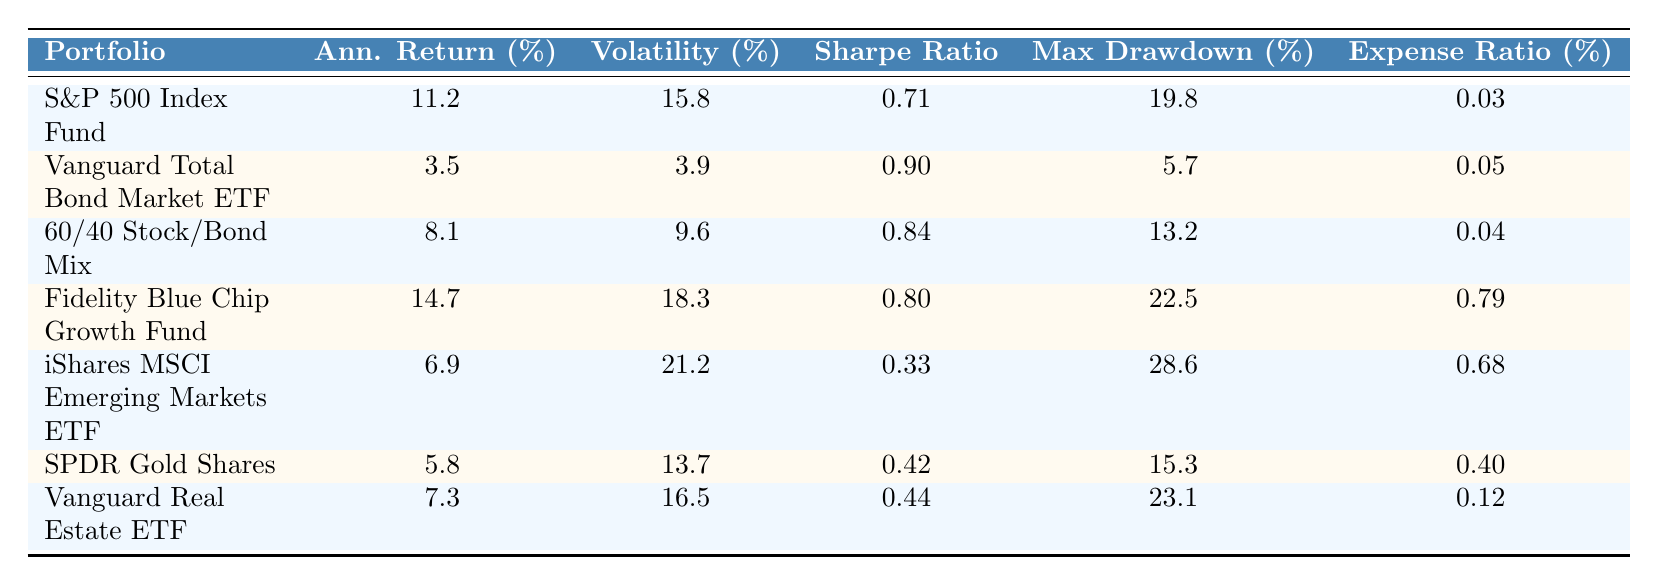What's the annualized return of the Fidelity Blue Chip Growth Fund? Referring to the table, the Fidelity Blue Chip Growth Fund's annualized return is explicitly listed as 14.7%.
Answer: 14.7% Which portfolio has the highest Sharpe Ratio? The Sharpe Ratio for each portfolio is compared. The Vanguard Total Bond Market ETF has a Sharpe Ratio of 0.90, which is the highest among all portfolios listed.
Answer: Vanguard Total Bond Market ETF What is the average maximum drawdown of all the portfolios? To find the average, sum the maximum drawdowns: 19.8 + 5.7 + 13.2 + 22.5 + 28.6 + 15.3 + 23.1 = 128.2. There are 7 portfolios, so the average is 128.2 / 7 ≈ 18.3%.
Answer: 18.3% Is the expense ratio of the iShares MSCI Emerging Markets ETF higher than that of the Vanguard Total Bond Market ETF? The expense ratio of the iShares MSCI Emerging Markets ETF is 0.68%, while the Vanguard Total Bond Market ETF's is 0.05%. Since 0.68% is greater than 0.05%, the statement is true.
Answer: Yes What is the difference in annualized return between the S&P 500 Index Fund and the 60/40 Stock/Bond Mix? The annualized return of the S&P 500 Index Fund is 11.2%, and for the 60/40 Stock/Bond Mix, it is 8.1%. The difference is 11.2 - 8.1 = 3.1%.
Answer: 3.1% Which portfolio has the lowest volatility, and what is that value? Upon examining the volatility values in the table, the Vanguard Total Bond Market ETF has the lowest volatility at 3.9%.
Answer: Vanguard Total Bond Market ETF, 3.9% If a new comparison is made based only on the maximum drawdown, which portfolio performs the best? The portfolio with the lowest maximum drawdown is the Vanguard Total Bond Market ETF at 5.7%. This indicates the best performance in terms of risk management concerning drawdowns.
Answer: Vanguard Total Bond Market ETF What is the total annualized return of the two highest-performing portfolios? The two highest annualized returns are from the Fidelity Blue Chip Growth Fund (14.7%) and the S&P 500 Index Fund (11.2%). Adding these yields 14.7 + 11.2 = 25.9%.
Answer: 25.9% 